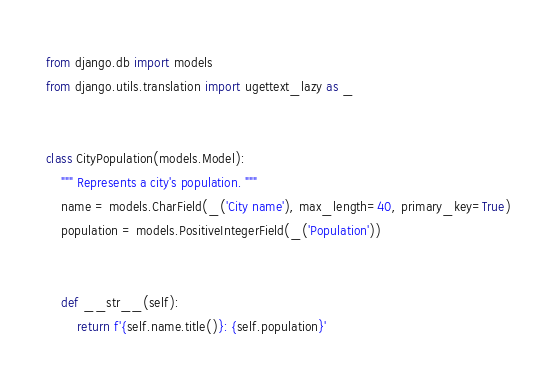<code> <loc_0><loc_0><loc_500><loc_500><_Python_>from django.db import models
from django.utils.translation import ugettext_lazy as _


class CityPopulation(models.Model):
    """ Represents a city's population. """
    name = models.CharField(_('City name'), max_length=40, primary_key=True)
    population = models.PositiveIntegerField(_('Population'))


    def __str__(self):
        return f'{self.name.title()}: {self.population}'
</code> 